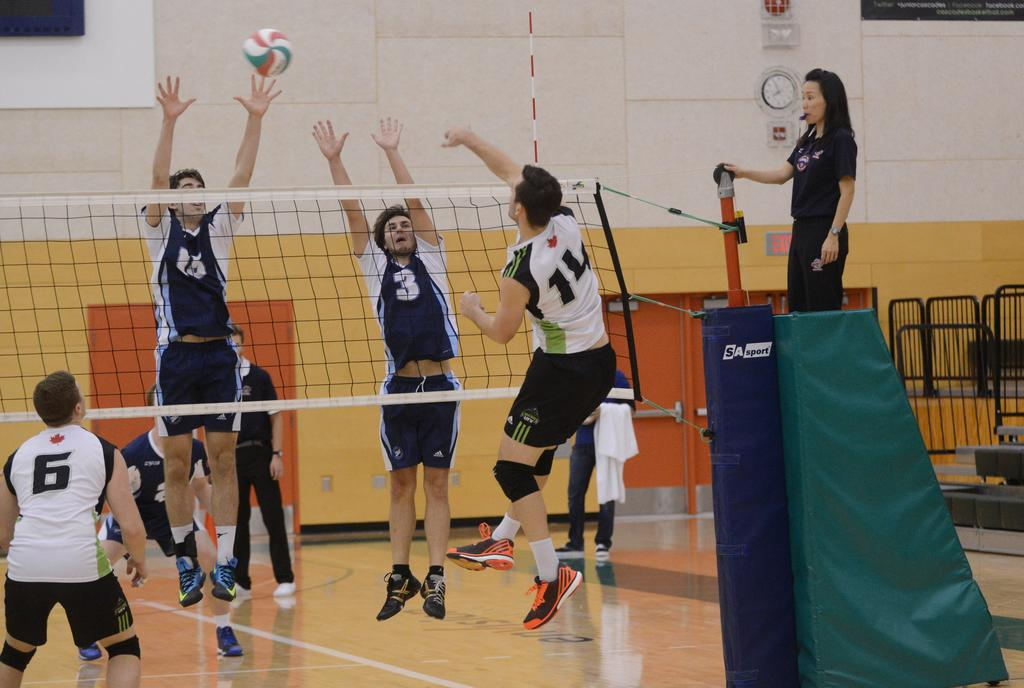<image>
Provide a brief description of the given image. Two teams are playing a volley game while there is an exit sign at the back. 